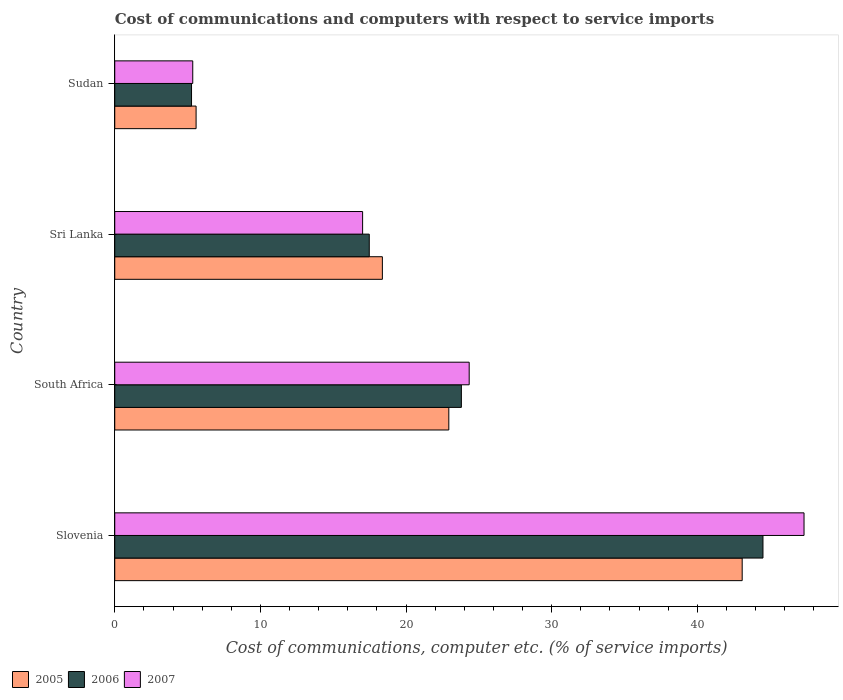Are the number of bars per tick equal to the number of legend labels?
Your answer should be compact. Yes. Are the number of bars on each tick of the Y-axis equal?
Your answer should be compact. Yes. How many bars are there on the 3rd tick from the bottom?
Offer a very short reply. 3. What is the label of the 3rd group of bars from the top?
Your answer should be very brief. South Africa. In how many cases, is the number of bars for a given country not equal to the number of legend labels?
Your answer should be very brief. 0. What is the cost of communications and computers in 2007 in South Africa?
Your response must be concise. 24.34. Across all countries, what is the maximum cost of communications and computers in 2006?
Ensure brevity in your answer.  44.51. Across all countries, what is the minimum cost of communications and computers in 2006?
Your answer should be very brief. 5.27. In which country was the cost of communications and computers in 2005 maximum?
Your response must be concise. Slovenia. In which country was the cost of communications and computers in 2005 minimum?
Offer a very short reply. Sudan. What is the total cost of communications and computers in 2005 in the graph?
Your answer should be compact. 89.99. What is the difference between the cost of communications and computers in 2005 in South Africa and that in Sudan?
Keep it short and to the point. 17.35. What is the difference between the cost of communications and computers in 2005 in Sri Lanka and the cost of communications and computers in 2007 in South Africa?
Provide a short and direct response. -5.96. What is the average cost of communications and computers in 2006 per country?
Your answer should be very brief. 22.77. What is the difference between the cost of communications and computers in 2005 and cost of communications and computers in 2006 in Sudan?
Your answer should be very brief. 0.31. What is the ratio of the cost of communications and computers in 2005 in Sri Lanka to that in Sudan?
Ensure brevity in your answer.  3.29. Is the cost of communications and computers in 2007 in South Africa less than that in Sri Lanka?
Provide a short and direct response. No. Is the difference between the cost of communications and computers in 2005 in Slovenia and Sudan greater than the difference between the cost of communications and computers in 2006 in Slovenia and Sudan?
Provide a short and direct response. No. What is the difference between the highest and the second highest cost of communications and computers in 2006?
Your answer should be compact. 20.71. What is the difference between the highest and the lowest cost of communications and computers in 2006?
Your answer should be compact. 39.24. In how many countries, is the cost of communications and computers in 2005 greater than the average cost of communications and computers in 2005 taken over all countries?
Ensure brevity in your answer.  2. Is the sum of the cost of communications and computers in 2005 in Slovenia and South Africa greater than the maximum cost of communications and computers in 2007 across all countries?
Your answer should be compact. Yes. Is it the case that in every country, the sum of the cost of communications and computers in 2005 and cost of communications and computers in 2007 is greater than the cost of communications and computers in 2006?
Your response must be concise. Yes. Are all the bars in the graph horizontal?
Your response must be concise. Yes. What is the difference between two consecutive major ticks on the X-axis?
Give a very brief answer. 10. Does the graph contain grids?
Your response must be concise. No. How many legend labels are there?
Your answer should be very brief. 3. How are the legend labels stacked?
Your answer should be very brief. Horizontal. What is the title of the graph?
Make the answer very short. Cost of communications and computers with respect to service imports. Does "1989" appear as one of the legend labels in the graph?
Offer a very short reply. No. What is the label or title of the X-axis?
Your answer should be very brief. Cost of communications, computer etc. (% of service imports). What is the label or title of the Y-axis?
Your answer should be compact. Country. What is the Cost of communications, computer etc. (% of service imports) in 2005 in Slovenia?
Ensure brevity in your answer.  43.08. What is the Cost of communications, computer etc. (% of service imports) of 2006 in Slovenia?
Keep it short and to the point. 44.51. What is the Cost of communications, computer etc. (% of service imports) of 2007 in Slovenia?
Provide a succinct answer. 47.33. What is the Cost of communications, computer etc. (% of service imports) in 2005 in South Africa?
Ensure brevity in your answer.  22.94. What is the Cost of communications, computer etc. (% of service imports) of 2006 in South Africa?
Your answer should be compact. 23.8. What is the Cost of communications, computer etc. (% of service imports) of 2007 in South Africa?
Ensure brevity in your answer.  24.34. What is the Cost of communications, computer etc. (% of service imports) of 2005 in Sri Lanka?
Offer a very short reply. 18.38. What is the Cost of communications, computer etc. (% of service imports) of 2006 in Sri Lanka?
Your answer should be very brief. 17.48. What is the Cost of communications, computer etc. (% of service imports) in 2007 in Sri Lanka?
Ensure brevity in your answer.  17.02. What is the Cost of communications, computer etc. (% of service imports) of 2005 in Sudan?
Offer a very short reply. 5.59. What is the Cost of communications, computer etc. (% of service imports) of 2006 in Sudan?
Provide a succinct answer. 5.27. What is the Cost of communications, computer etc. (% of service imports) in 2007 in Sudan?
Make the answer very short. 5.36. Across all countries, what is the maximum Cost of communications, computer etc. (% of service imports) of 2005?
Offer a very short reply. 43.08. Across all countries, what is the maximum Cost of communications, computer etc. (% of service imports) of 2006?
Offer a terse response. 44.51. Across all countries, what is the maximum Cost of communications, computer etc. (% of service imports) in 2007?
Ensure brevity in your answer.  47.33. Across all countries, what is the minimum Cost of communications, computer etc. (% of service imports) in 2005?
Make the answer very short. 5.59. Across all countries, what is the minimum Cost of communications, computer etc. (% of service imports) of 2006?
Make the answer very short. 5.27. Across all countries, what is the minimum Cost of communications, computer etc. (% of service imports) in 2007?
Offer a very short reply. 5.36. What is the total Cost of communications, computer etc. (% of service imports) in 2005 in the graph?
Give a very brief answer. 89.99. What is the total Cost of communications, computer etc. (% of service imports) in 2006 in the graph?
Your answer should be compact. 91.06. What is the total Cost of communications, computer etc. (% of service imports) in 2007 in the graph?
Give a very brief answer. 94.05. What is the difference between the Cost of communications, computer etc. (% of service imports) in 2005 in Slovenia and that in South Africa?
Offer a terse response. 20.15. What is the difference between the Cost of communications, computer etc. (% of service imports) of 2006 in Slovenia and that in South Africa?
Your response must be concise. 20.71. What is the difference between the Cost of communications, computer etc. (% of service imports) of 2007 in Slovenia and that in South Africa?
Your response must be concise. 22.99. What is the difference between the Cost of communications, computer etc. (% of service imports) of 2005 in Slovenia and that in Sri Lanka?
Ensure brevity in your answer.  24.71. What is the difference between the Cost of communications, computer etc. (% of service imports) in 2006 in Slovenia and that in Sri Lanka?
Provide a succinct answer. 27.04. What is the difference between the Cost of communications, computer etc. (% of service imports) of 2007 in Slovenia and that in Sri Lanka?
Your answer should be very brief. 30.31. What is the difference between the Cost of communications, computer etc. (% of service imports) in 2005 in Slovenia and that in Sudan?
Give a very brief answer. 37.5. What is the difference between the Cost of communications, computer etc. (% of service imports) of 2006 in Slovenia and that in Sudan?
Provide a succinct answer. 39.24. What is the difference between the Cost of communications, computer etc. (% of service imports) of 2007 in Slovenia and that in Sudan?
Ensure brevity in your answer.  41.98. What is the difference between the Cost of communications, computer etc. (% of service imports) in 2005 in South Africa and that in Sri Lanka?
Make the answer very short. 4.56. What is the difference between the Cost of communications, computer etc. (% of service imports) in 2006 in South Africa and that in Sri Lanka?
Offer a very short reply. 6.33. What is the difference between the Cost of communications, computer etc. (% of service imports) in 2007 in South Africa and that in Sri Lanka?
Ensure brevity in your answer.  7.32. What is the difference between the Cost of communications, computer etc. (% of service imports) in 2005 in South Africa and that in Sudan?
Ensure brevity in your answer.  17.35. What is the difference between the Cost of communications, computer etc. (% of service imports) of 2006 in South Africa and that in Sudan?
Provide a succinct answer. 18.53. What is the difference between the Cost of communications, computer etc. (% of service imports) in 2007 in South Africa and that in Sudan?
Offer a terse response. 18.98. What is the difference between the Cost of communications, computer etc. (% of service imports) of 2005 in Sri Lanka and that in Sudan?
Keep it short and to the point. 12.79. What is the difference between the Cost of communications, computer etc. (% of service imports) in 2006 in Sri Lanka and that in Sudan?
Give a very brief answer. 12.2. What is the difference between the Cost of communications, computer etc. (% of service imports) of 2007 in Sri Lanka and that in Sudan?
Make the answer very short. 11.66. What is the difference between the Cost of communications, computer etc. (% of service imports) of 2005 in Slovenia and the Cost of communications, computer etc. (% of service imports) of 2006 in South Africa?
Your answer should be compact. 19.28. What is the difference between the Cost of communications, computer etc. (% of service imports) of 2005 in Slovenia and the Cost of communications, computer etc. (% of service imports) of 2007 in South Africa?
Provide a short and direct response. 18.75. What is the difference between the Cost of communications, computer etc. (% of service imports) of 2006 in Slovenia and the Cost of communications, computer etc. (% of service imports) of 2007 in South Africa?
Keep it short and to the point. 20.17. What is the difference between the Cost of communications, computer etc. (% of service imports) of 2005 in Slovenia and the Cost of communications, computer etc. (% of service imports) of 2006 in Sri Lanka?
Ensure brevity in your answer.  25.61. What is the difference between the Cost of communications, computer etc. (% of service imports) of 2005 in Slovenia and the Cost of communications, computer etc. (% of service imports) of 2007 in Sri Lanka?
Offer a very short reply. 26.07. What is the difference between the Cost of communications, computer etc. (% of service imports) in 2006 in Slovenia and the Cost of communications, computer etc. (% of service imports) in 2007 in Sri Lanka?
Keep it short and to the point. 27.49. What is the difference between the Cost of communications, computer etc. (% of service imports) of 2005 in Slovenia and the Cost of communications, computer etc. (% of service imports) of 2006 in Sudan?
Your answer should be very brief. 37.81. What is the difference between the Cost of communications, computer etc. (% of service imports) in 2005 in Slovenia and the Cost of communications, computer etc. (% of service imports) in 2007 in Sudan?
Your answer should be very brief. 37.73. What is the difference between the Cost of communications, computer etc. (% of service imports) in 2006 in Slovenia and the Cost of communications, computer etc. (% of service imports) in 2007 in Sudan?
Your response must be concise. 39.16. What is the difference between the Cost of communications, computer etc. (% of service imports) in 2005 in South Africa and the Cost of communications, computer etc. (% of service imports) in 2006 in Sri Lanka?
Offer a terse response. 5.46. What is the difference between the Cost of communications, computer etc. (% of service imports) of 2005 in South Africa and the Cost of communications, computer etc. (% of service imports) of 2007 in Sri Lanka?
Offer a terse response. 5.92. What is the difference between the Cost of communications, computer etc. (% of service imports) in 2006 in South Africa and the Cost of communications, computer etc. (% of service imports) in 2007 in Sri Lanka?
Provide a short and direct response. 6.78. What is the difference between the Cost of communications, computer etc. (% of service imports) in 2005 in South Africa and the Cost of communications, computer etc. (% of service imports) in 2006 in Sudan?
Make the answer very short. 17.67. What is the difference between the Cost of communications, computer etc. (% of service imports) in 2005 in South Africa and the Cost of communications, computer etc. (% of service imports) in 2007 in Sudan?
Keep it short and to the point. 17.58. What is the difference between the Cost of communications, computer etc. (% of service imports) of 2006 in South Africa and the Cost of communications, computer etc. (% of service imports) of 2007 in Sudan?
Your answer should be compact. 18.45. What is the difference between the Cost of communications, computer etc. (% of service imports) in 2005 in Sri Lanka and the Cost of communications, computer etc. (% of service imports) in 2006 in Sudan?
Your answer should be compact. 13.1. What is the difference between the Cost of communications, computer etc. (% of service imports) of 2005 in Sri Lanka and the Cost of communications, computer etc. (% of service imports) of 2007 in Sudan?
Your response must be concise. 13.02. What is the difference between the Cost of communications, computer etc. (% of service imports) of 2006 in Sri Lanka and the Cost of communications, computer etc. (% of service imports) of 2007 in Sudan?
Ensure brevity in your answer.  12.12. What is the average Cost of communications, computer etc. (% of service imports) of 2005 per country?
Offer a terse response. 22.5. What is the average Cost of communications, computer etc. (% of service imports) of 2006 per country?
Ensure brevity in your answer.  22.77. What is the average Cost of communications, computer etc. (% of service imports) in 2007 per country?
Give a very brief answer. 23.51. What is the difference between the Cost of communications, computer etc. (% of service imports) in 2005 and Cost of communications, computer etc. (% of service imports) in 2006 in Slovenia?
Your response must be concise. -1.43. What is the difference between the Cost of communications, computer etc. (% of service imports) of 2005 and Cost of communications, computer etc. (% of service imports) of 2007 in Slovenia?
Give a very brief answer. -4.25. What is the difference between the Cost of communications, computer etc. (% of service imports) in 2006 and Cost of communications, computer etc. (% of service imports) in 2007 in Slovenia?
Give a very brief answer. -2.82. What is the difference between the Cost of communications, computer etc. (% of service imports) of 2005 and Cost of communications, computer etc. (% of service imports) of 2006 in South Africa?
Offer a terse response. -0.86. What is the difference between the Cost of communications, computer etc. (% of service imports) in 2005 and Cost of communications, computer etc. (% of service imports) in 2007 in South Africa?
Your answer should be compact. -1.4. What is the difference between the Cost of communications, computer etc. (% of service imports) in 2006 and Cost of communications, computer etc. (% of service imports) in 2007 in South Africa?
Keep it short and to the point. -0.54. What is the difference between the Cost of communications, computer etc. (% of service imports) in 2005 and Cost of communications, computer etc. (% of service imports) in 2006 in Sri Lanka?
Your answer should be compact. 0.9. What is the difference between the Cost of communications, computer etc. (% of service imports) in 2005 and Cost of communications, computer etc. (% of service imports) in 2007 in Sri Lanka?
Offer a terse response. 1.36. What is the difference between the Cost of communications, computer etc. (% of service imports) in 2006 and Cost of communications, computer etc. (% of service imports) in 2007 in Sri Lanka?
Ensure brevity in your answer.  0.46. What is the difference between the Cost of communications, computer etc. (% of service imports) in 2005 and Cost of communications, computer etc. (% of service imports) in 2006 in Sudan?
Your answer should be compact. 0.31. What is the difference between the Cost of communications, computer etc. (% of service imports) of 2005 and Cost of communications, computer etc. (% of service imports) of 2007 in Sudan?
Keep it short and to the point. 0.23. What is the difference between the Cost of communications, computer etc. (% of service imports) of 2006 and Cost of communications, computer etc. (% of service imports) of 2007 in Sudan?
Ensure brevity in your answer.  -0.08. What is the ratio of the Cost of communications, computer etc. (% of service imports) in 2005 in Slovenia to that in South Africa?
Provide a short and direct response. 1.88. What is the ratio of the Cost of communications, computer etc. (% of service imports) in 2006 in Slovenia to that in South Africa?
Make the answer very short. 1.87. What is the ratio of the Cost of communications, computer etc. (% of service imports) of 2007 in Slovenia to that in South Africa?
Provide a short and direct response. 1.94. What is the ratio of the Cost of communications, computer etc. (% of service imports) of 2005 in Slovenia to that in Sri Lanka?
Provide a succinct answer. 2.34. What is the ratio of the Cost of communications, computer etc. (% of service imports) of 2006 in Slovenia to that in Sri Lanka?
Your response must be concise. 2.55. What is the ratio of the Cost of communications, computer etc. (% of service imports) in 2007 in Slovenia to that in Sri Lanka?
Offer a very short reply. 2.78. What is the ratio of the Cost of communications, computer etc. (% of service imports) of 2005 in Slovenia to that in Sudan?
Make the answer very short. 7.71. What is the ratio of the Cost of communications, computer etc. (% of service imports) of 2006 in Slovenia to that in Sudan?
Offer a terse response. 8.44. What is the ratio of the Cost of communications, computer etc. (% of service imports) in 2007 in Slovenia to that in Sudan?
Keep it short and to the point. 8.84. What is the ratio of the Cost of communications, computer etc. (% of service imports) of 2005 in South Africa to that in Sri Lanka?
Provide a succinct answer. 1.25. What is the ratio of the Cost of communications, computer etc. (% of service imports) of 2006 in South Africa to that in Sri Lanka?
Ensure brevity in your answer.  1.36. What is the ratio of the Cost of communications, computer etc. (% of service imports) of 2007 in South Africa to that in Sri Lanka?
Your response must be concise. 1.43. What is the ratio of the Cost of communications, computer etc. (% of service imports) in 2005 in South Africa to that in Sudan?
Give a very brief answer. 4.11. What is the ratio of the Cost of communications, computer etc. (% of service imports) of 2006 in South Africa to that in Sudan?
Ensure brevity in your answer.  4.51. What is the ratio of the Cost of communications, computer etc. (% of service imports) of 2007 in South Africa to that in Sudan?
Offer a very short reply. 4.54. What is the ratio of the Cost of communications, computer etc. (% of service imports) of 2005 in Sri Lanka to that in Sudan?
Give a very brief answer. 3.29. What is the ratio of the Cost of communications, computer etc. (% of service imports) in 2006 in Sri Lanka to that in Sudan?
Your answer should be very brief. 3.31. What is the ratio of the Cost of communications, computer etc. (% of service imports) of 2007 in Sri Lanka to that in Sudan?
Give a very brief answer. 3.18. What is the difference between the highest and the second highest Cost of communications, computer etc. (% of service imports) of 2005?
Make the answer very short. 20.15. What is the difference between the highest and the second highest Cost of communications, computer etc. (% of service imports) in 2006?
Your answer should be very brief. 20.71. What is the difference between the highest and the second highest Cost of communications, computer etc. (% of service imports) of 2007?
Provide a short and direct response. 22.99. What is the difference between the highest and the lowest Cost of communications, computer etc. (% of service imports) in 2005?
Your response must be concise. 37.5. What is the difference between the highest and the lowest Cost of communications, computer etc. (% of service imports) in 2006?
Ensure brevity in your answer.  39.24. What is the difference between the highest and the lowest Cost of communications, computer etc. (% of service imports) in 2007?
Your answer should be compact. 41.98. 